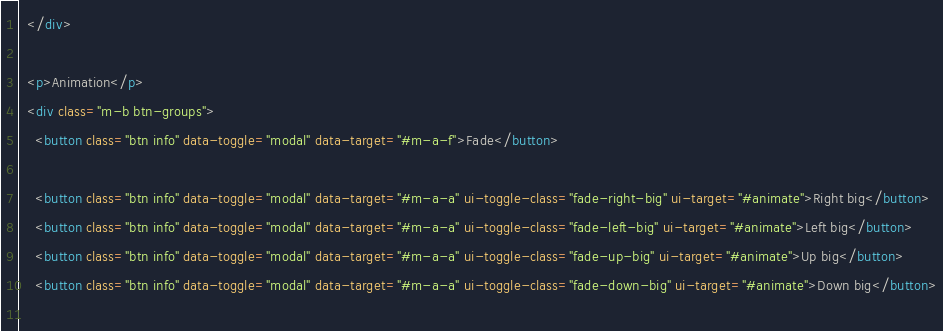<code> <loc_0><loc_0><loc_500><loc_500><_HTML_>  </div>

  <p>Animation</p>
  <div class="m-b btn-groups">
  	<button class="btn info" data-toggle="modal" data-target="#m-a-f">Fade</button>

  	<button class="btn info" data-toggle="modal" data-target="#m-a-a" ui-toggle-class="fade-right-big" ui-target="#animate">Right big</button>
  	<button class="btn info" data-toggle="modal" data-target="#m-a-a" ui-toggle-class="fade-left-big" ui-target="#animate">Left big</button>
  	<button class="btn info" data-toggle="modal" data-target="#m-a-a" ui-toggle-class="fade-up-big" ui-target="#animate">Up big</button>
  	<button class="btn info" data-toggle="modal" data-target="#m-a-a" ui-toggle-class="fade-down-big" ui-target="#animate">Down big</button>
  	</code> 